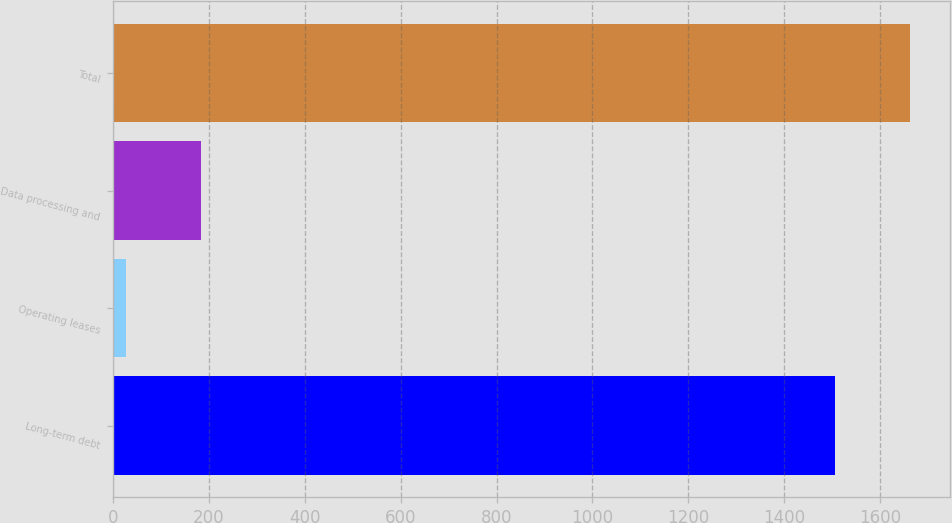Convert chart. <chart><loc_0><loc_0><loc_500><loc_500><bar_chart><fcel>Long-term debt<fcel>Operating leases<fcel>Data processing and<fcel>Total<nl><fcel>1504.8<fcel>27.8<fcel>184.57<fcel>1661.57<nl></chart> 